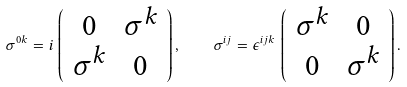<formula> <loc_0><loc_0><loc_500><loc_500>\sigma ^ { 0 k } = i \, \left ( \begin{array} { c c } 0 & \sigma ^ { k } \\ \sigma ^ { k } & 0 \end{array} \right ) , \quad \sigma ^ { i j } = \epsilon ^ { i j k } \, \left ( \begin{array} { c c } \sigma ^ { k } & 0 \\ 0 & \sigma ^ { k } \end{array} \right ) .</formula> 